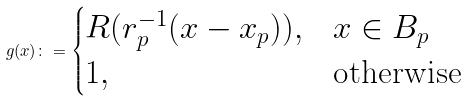<formula> <loc_0><loc_0><loc_500><loc_500>g ( x ) \colon = \begin{cases} R ( r _ { p } ^ { - 1 } ( x - x _ { p } ) ) , & x \in B _ { p } \\ 1 , & \text {otherwise} \end{cases}</formula> 